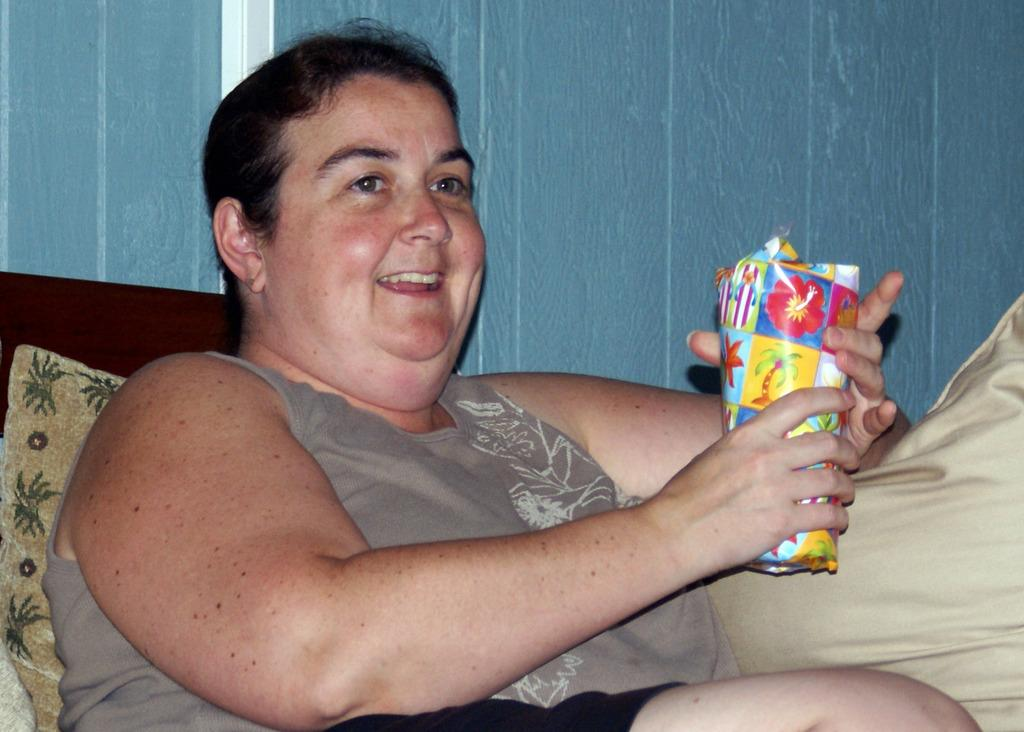What is the main subject of the image? The main subject of the image is a woman. What is the woman doing in the image? The woman is holding an object with her hands and smiling. What can be seen in the background of the image? There is a wall in the background of the image. What type of pain is the woman experiencing in the image? There is no indication of pain in the image; the woman is smiling. 